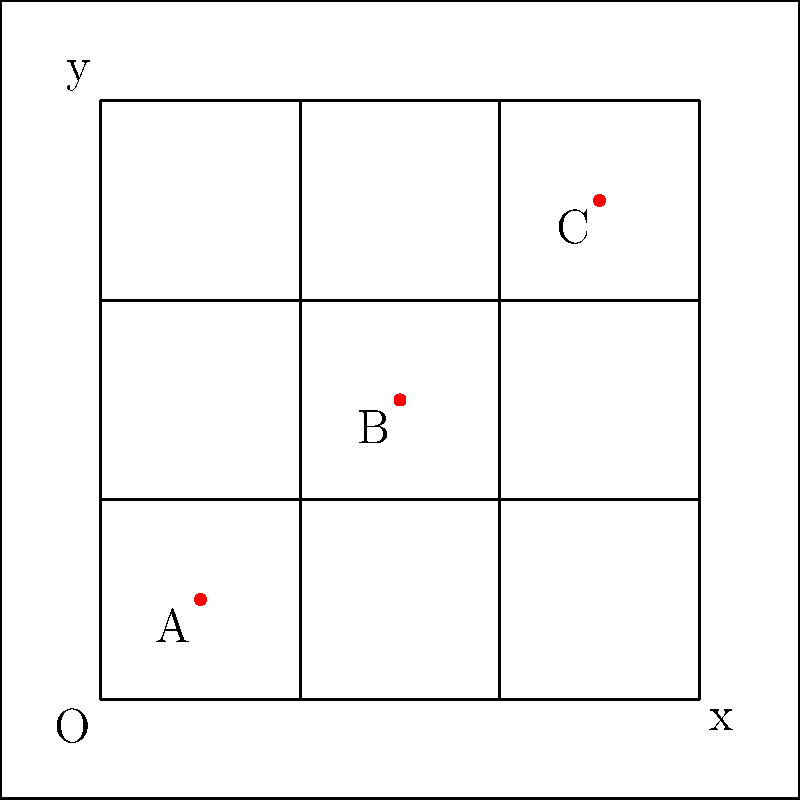In a Renaissance painting, an artist has created an irregular shape within a coordinate system. Three key points of this shape are labeled A(1,1), B(3,3), and C(5,5). Assuming these points form a triangle, calculate the area of this triangle using coordinate geometry methods. How does this area compare to the total area of the 6x6 grid in which it's inscribed? Express your answer as a fraction of the total grid area. Let's approach this step-by-step:

1) First, we need to calculate the area of triangle ABC. We can use the formula for the area of a triangle given the coordinates of its vertices:

   Area = $\frac{1}{2}|x_1(y_2 - y_3) + x_2(y_3 - y_1) + x_3(y_1 - y_2)|$

   Where $(x_1,y_1)$, $(x_2,y_2)$, and $(x_3,y_3)$ are the coordinates of the three vertices.

2) Substituting our points:
   A(1,1), B(3,3), C(5,5)

   Area = $\frac{1}{2}|1(3 - 5) + 3(5 - 1) + 5(1 - 3)|$
        = $\frac{1}{2}|1(-2) + 3(4) + 5(-2)|$
        = $\frac{1}{2}|-2 + 12 - 10|$
        = $\frac{1}{2}|0|$
        = 0

3) The area of the triangle is 0, which means the three points are collinear (they lie on the same straight line).

4) The total area of the 6x6 grid is simply 6 * 6 = 36 square units.

5) The area of the triangle (0) as a fraction of the total grid area (36) is:

   $\frac{0}{36} = 0$

Therefore, the area of the triangle is 0, which is 0/36 or simply 0 of the total grid area.
Answer: 0 